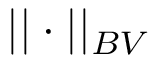<formula> <loc_0><loc_0><loc_500><loc_500>| | \cdot | | _ { B V }</formula> 